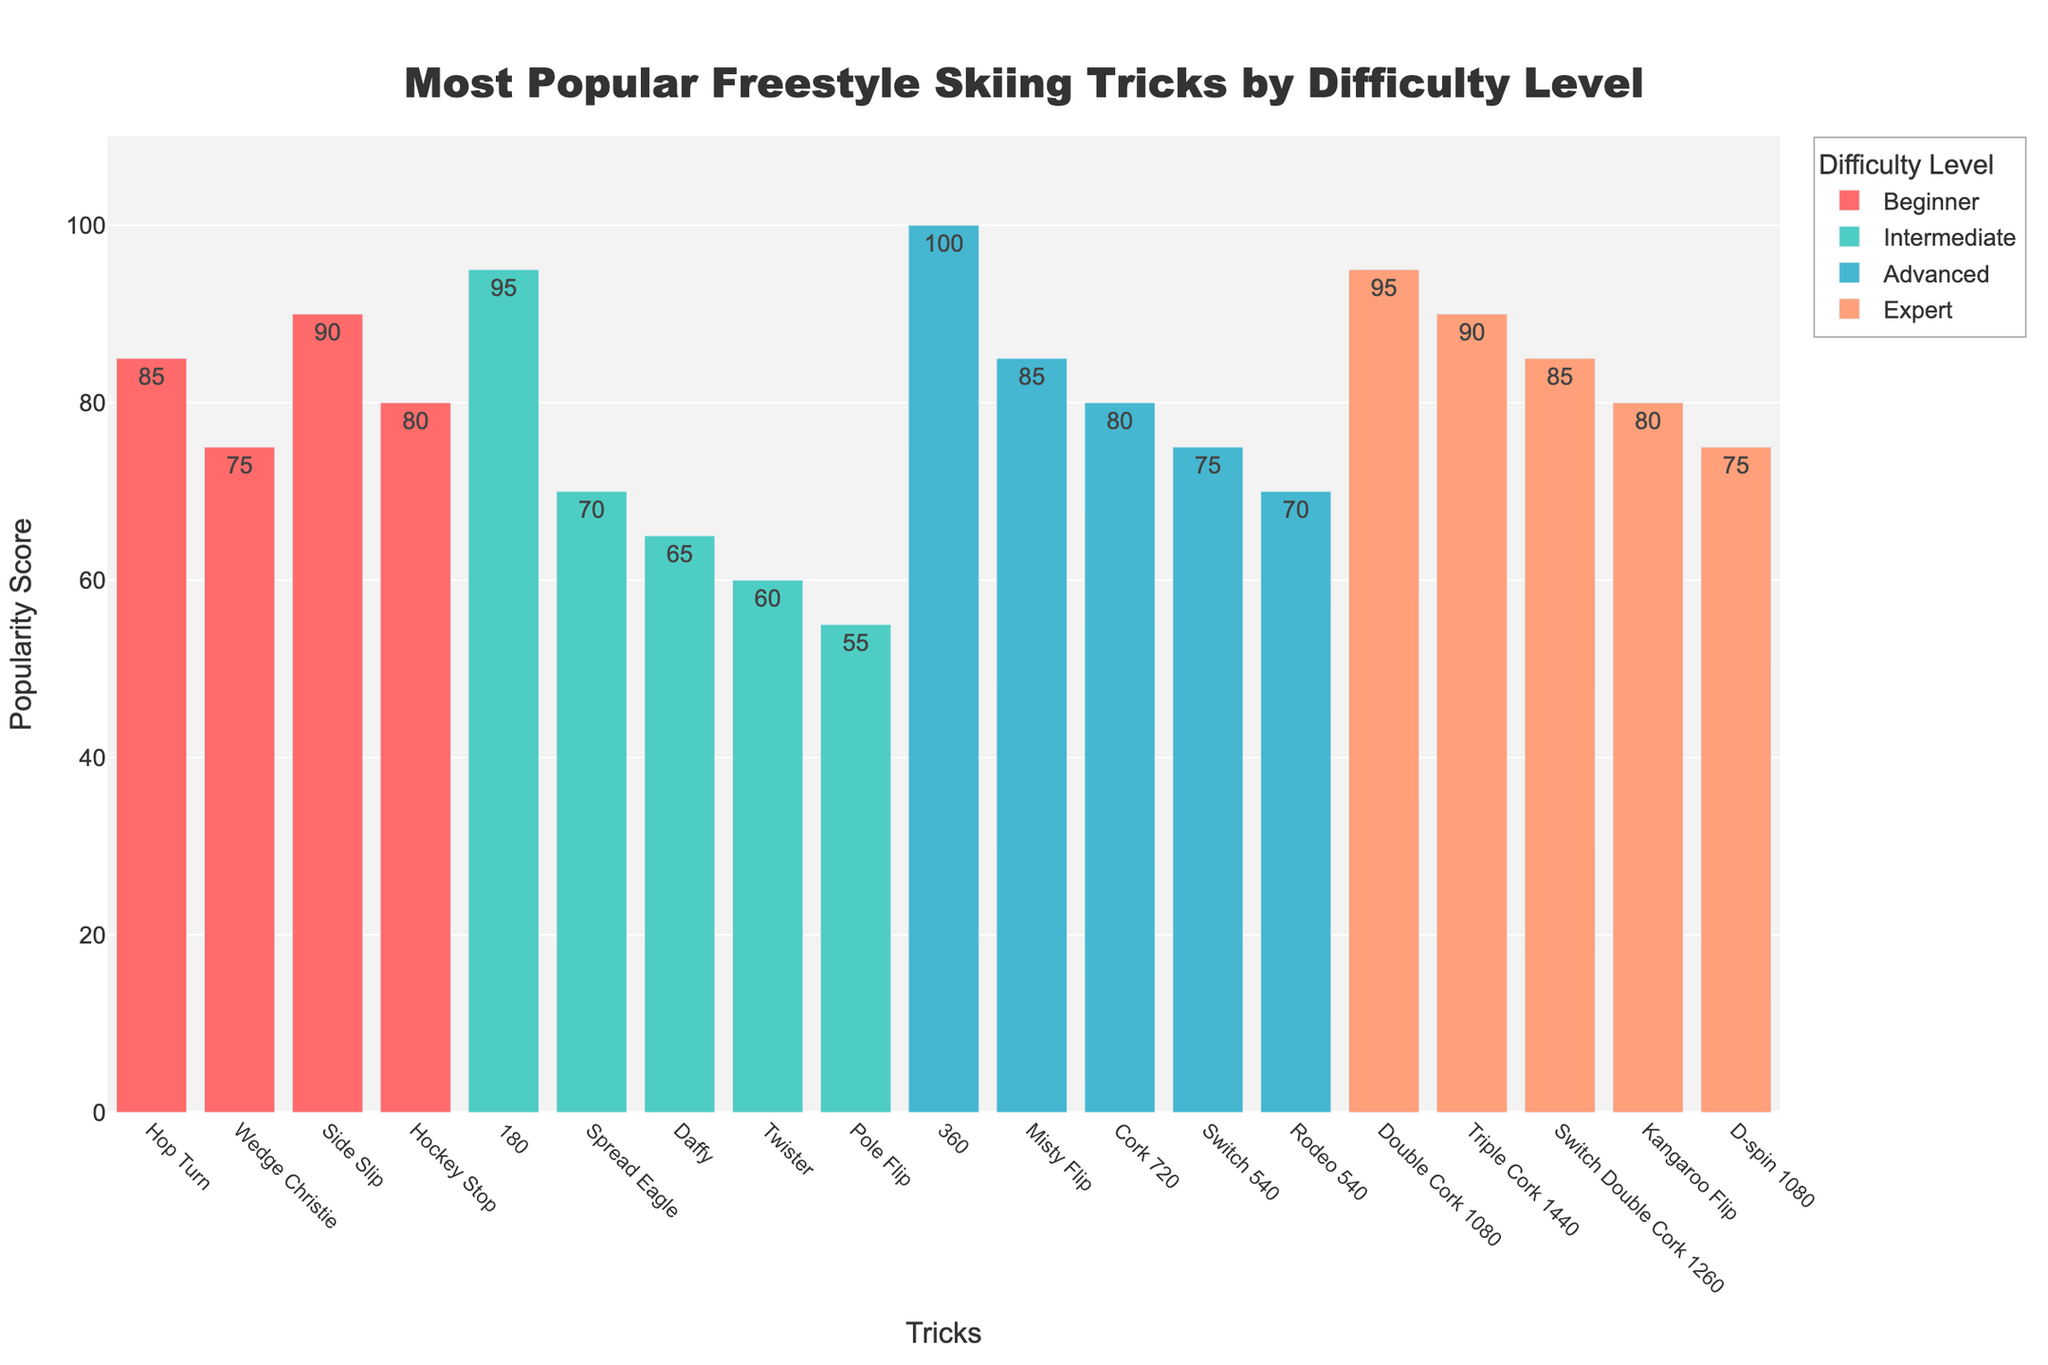What is the most popular freestyle skiing trick for beginners? By looking at the highest bar in the 'Beginner' category, we see that the Side Slip trick has the highest popularity score.
Answer: Side Slip How does the popularity of the 360 trick compare to the Switch 540 trick? In the 'Advanced' category, the 360 trick has a popularity score of 100, while the Switch 540 trick has a score of 75. Therefore, the 360 trick is more popular.
Answer: 360 trick is more popular Which trick has the lowest popularity among intermediate tricks? Among the 'Intermediate' category, the Pole Flip trick has the lowest bar, indicating a popularity score of 55.
Answer: Pole Flip What is the total popularity score of all expert tricks? The total popularity score can be calculated by summing the popularity scores of all the expert tricks: Double Cork 1080 (95) + Triple Cork 1440 (90) + Switch Double Cork 1260 (85) + Kangaroo Flip (80) + D-spin 1080 (75) = 425.
Answer: 425 Which difficulty level has the largest range in popularity scores? To determine the range, we subtract the lowest score from the highest score within each difficulty level. For Beginner: 90-75 = 15, Intermediate: 95-55 = 40, Advanced: 100-70 = 30, Expert: 95-75 = 20. Therefore, Intermediate has the largest range.
Answer: Intermediate What is the average popularity score for Intermediate tricks? The average can be found by adding up all the popularity scores for Intermediate tricks and dividing by the number of tricks. (95 + 70 + 65 + 60 + 55) / 5 = 69.
Answer: 69 Is there any trick in the Intermediate category that has a higher popularity score than the highest Beginner trick? The highest score in the Beginner category is 90 for Side Slip. The Intermediate trick 180 has a score of 95, which is higher than 90.
Answer: Yes How does the popularity score for Misty Flip compare to Double Cork 1080? For the Advanced category, the Misty Flip has a score of 85, while for Expert category, the Double Cork 1080 has a score of 95. Thus, the Double Cork 1080 is more popular.
Answer: Double Cork 1080 is more popular Which difficulty level contains the most tricks with a popularity score of 75 or higher? Counting the bars with a popularity score of 75 or above in each difficulty level, we get Beginner: 3 (Hop Turn, Side Slip, Hockey Stop), Intermediate: 1 (180), Advanced: 2 (360, Misty Flip), and Expert: 5 (all expert tricks). The Expert category contains the most tricks with a score of 75 or higher.
Answer: Expert Which Intermediate trick is nearest in popularity to the Wedge Christie trick in the Beginner category? The Wedge Christie has a score of 75 in the Beginner category. In Intermediate tricks, the nearest score is the Spread Eagle with a score of 70.
Answer: Spread Eagle 